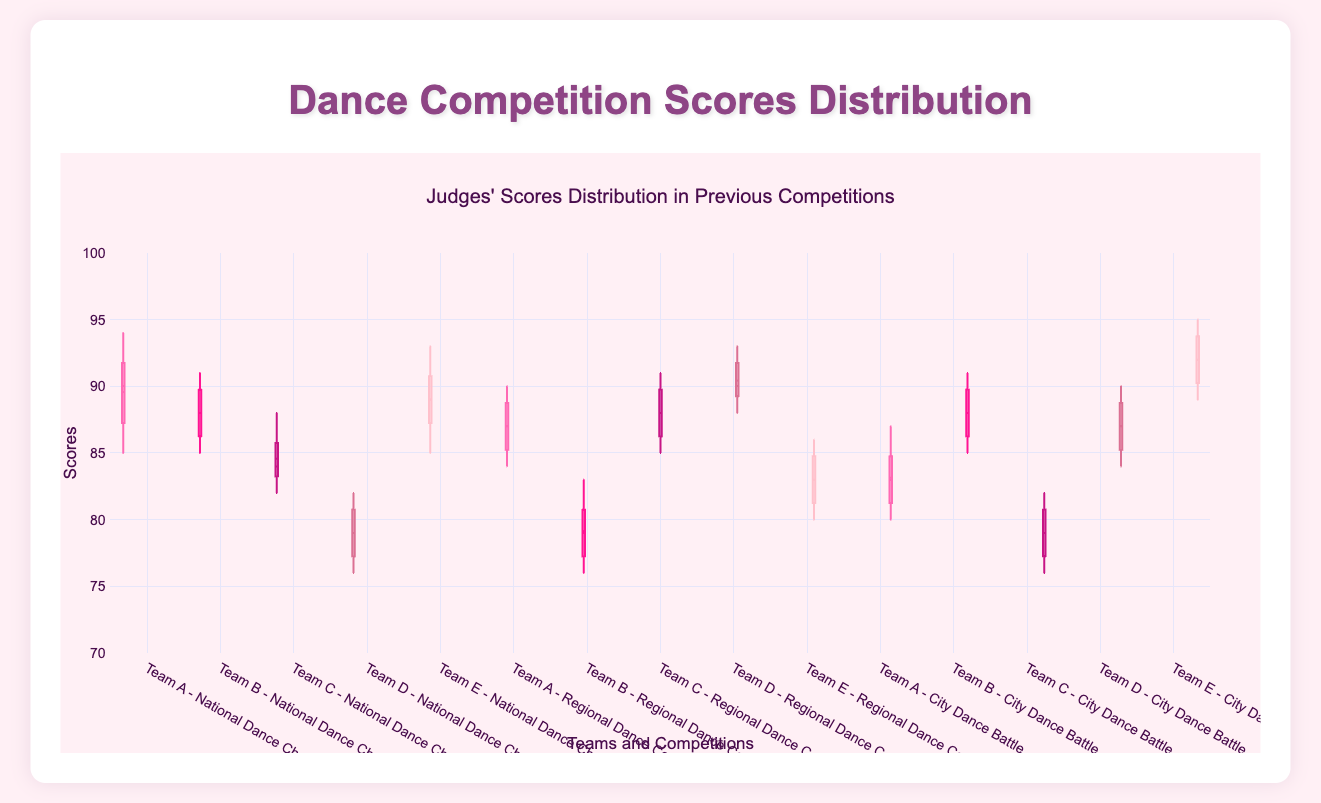What are the median scores for Team A in the National Dance Championship? The box plot shows the median score as a line within the box for each team's scores. For Team A in the National Dance Championship, the median score can be found by locating the corresponding line within the box on the plot.
Answer: 90 Which team had the highest score in the City Dance Battle? To determine the team with the highest score, look at the upper whiskers of the box plots for the City Dance Battle. The team with the highest position of the upper whisker will be the one with the highest score.
Answer: Team E What is the range of scores for Team B in the Regional Dance Contest? The range of a team's scores in a box plot is represented by the distance between the bottom of the lower whisker and the top of the upper whisker. For Team B in the Regional Dance Contest, identify the lowest and highest values from the plot and subtract the lowest from the highest to get the range.
Answer: 83 - 76 = 7 How do the median scores of Team D and Team E compare in the National Dance Championship? Compare the positions of the median lines (within the boxes) for Team D and Team E in the National Dance Championship. The higher median line indicates the team with the higher median score.
Answer: Team E's median score is higher than Team D's Which team had the most consistent scores across different competitions? Consistency in scores is indicated by the size of the interquartile range (IQR), which is the height of the box. The smaller the IQR, the more consistent the scores. Compare the heights of the boxes for all teams across all competitions to identify the team with the smallest boxes.
Answer: Team D What is the interquartile range (IQR) for Team C in the City Dance Battle? The IQR is the difference between the third quartile (Q3) and the first quartile (Q1). In a box plot, this is the height of the box. For Team C in the City Dance Battle, locate the values of Q3 and Q1 on the plot and subtract Q1 from Q3.
Answer: 81 - 78 = 3 Which team's scores in the Regional Dance Contest have the largest spread? The largest spread in scores is indicated by the total range, represented by the distance between the lowest point of the lower whisker and the highest value of the upper whisker in the box plot. Compare these distances for each team in the Regional Dance Contest.
Answer: Team B Compare the overall performance of Team A across all competitions based on the median scores. To compare the overall performance of Team A, observe the median lines within their boxes across all three competitions. Note any changes in the position of these lines (higher or lower) to compare performance.
Answer: Team A's median score decreases from the National Dance Championship to the City Dance Battle 